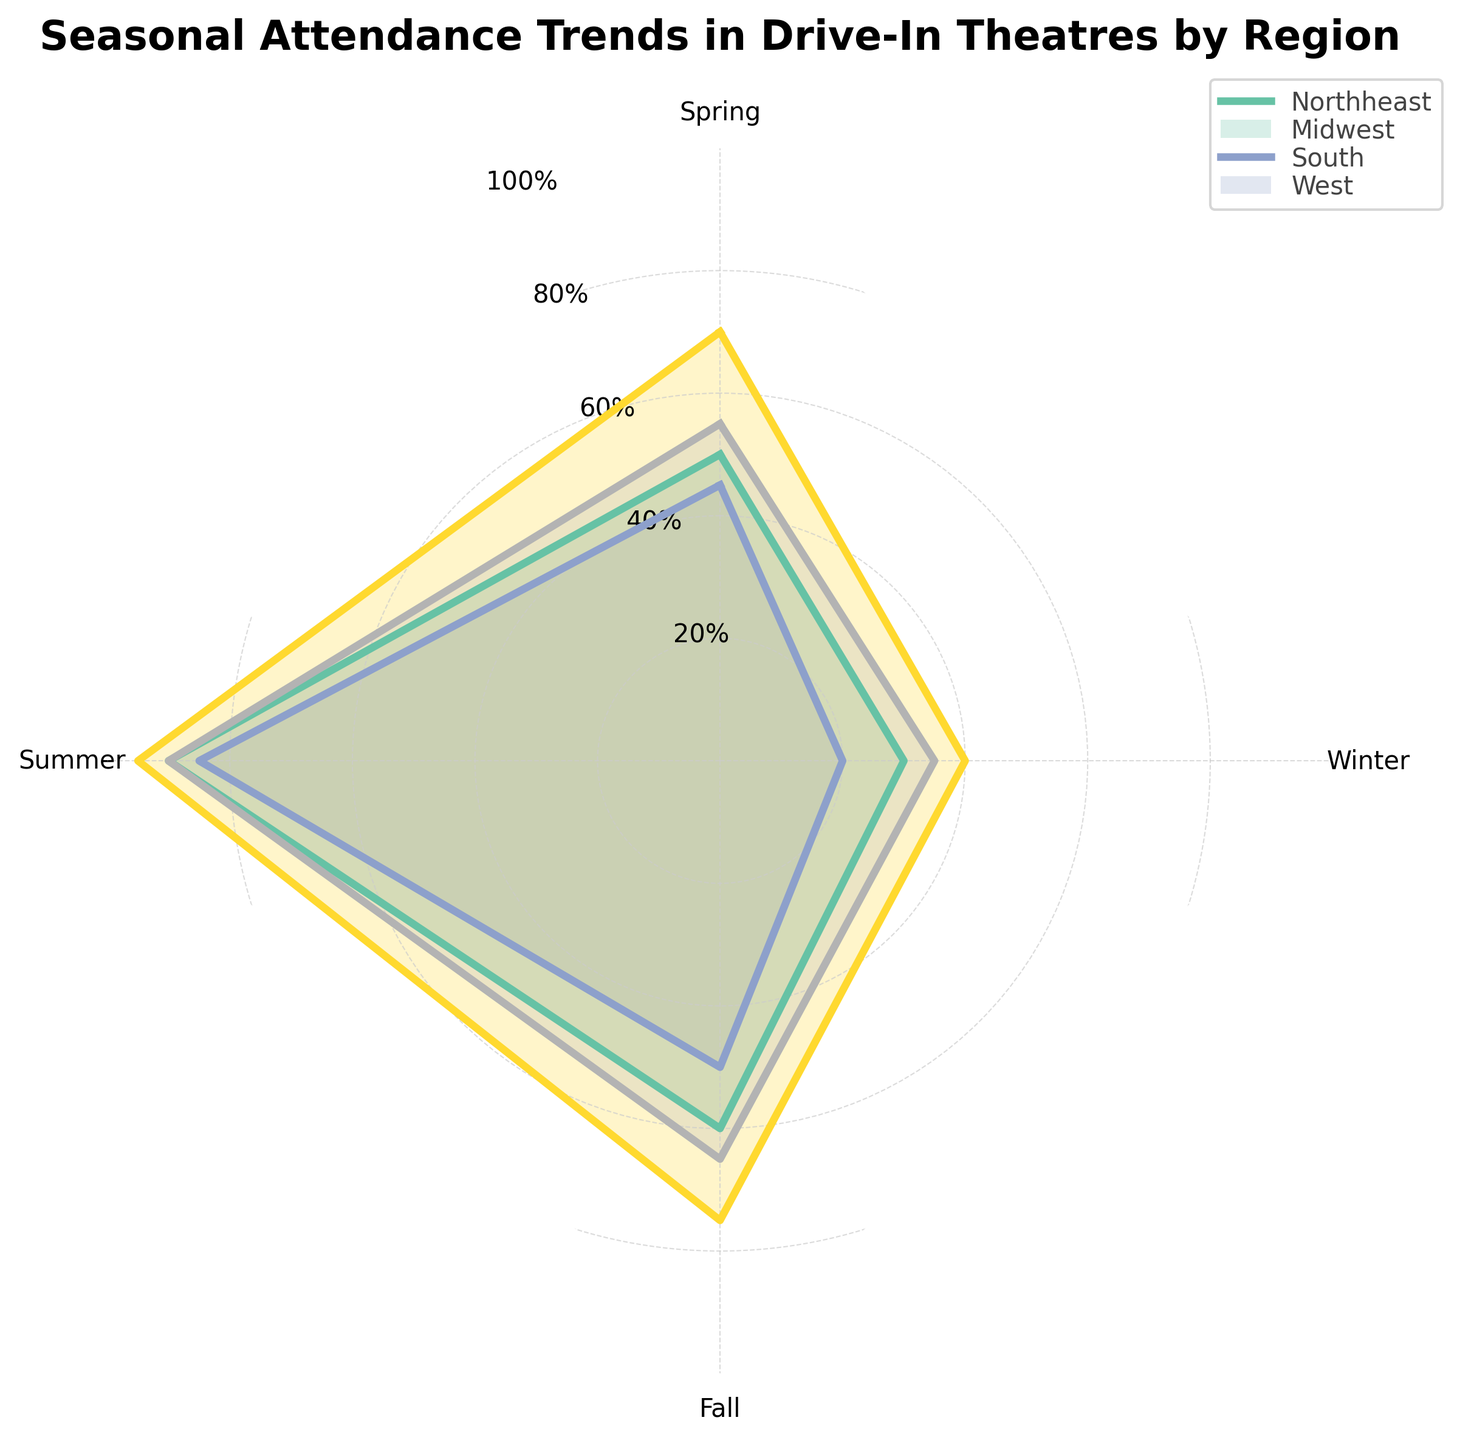what is the title of the figure? The title is usually found at the top of the figure. Here, the title is written as "Seasonal Attendance Trends in Drive-In Theatres by Region" in bold format.
Answer: Seasonal Attendance Trends in Drive-In Theatres by Region How many regions are compared in the figure? We look at the legend or the different colored areas/polygons on the radar chart. Each color represents one of the regions. Checking the legend, there are four regions listed.
Answer: 4 Which region has the highest attendance in Winter? We check the colored areas corresponding to each region for the Winter season, which is one of the axes. By comparing the points where each region's line intersects with the Winter axis, the region with the highest value can be determined. The South has the highest value at 40%.
Answer: South What's the average attendance for the Northeast across all seasons? First, find the Northeast attendance values for all seasons (50, 90, 60, 30). Then, add these values and divide by the number of seasons. Average = (50+90+60+30)/4
Answer: 57.5 Compare the attendance of the South in Spring and Winter. Which is higher and by how much? Identify the attendance values for the South in Spring (70) and Winter (40). Calculate the difference: 70 - 40 = 30. So, Spring is higher by 30%.
Answer: Spring by 30 